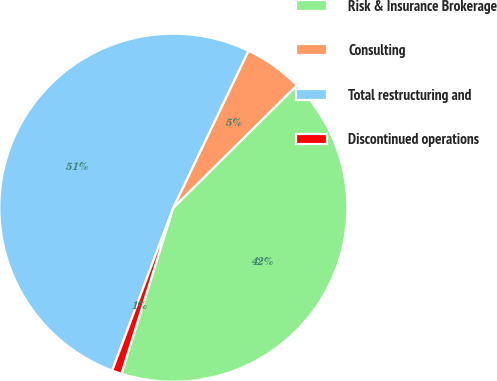Convert chart. <chart><loc_0><loc_0><loc_500><loc_500><pie_chart><fcel>Risk & Insurance Brokerage<fcel>Consulting<fcel>Total restructuring and<fcel>Discontinued operations<nl><fcel>42.25%<fcel>5.47%<fcel>51.4%<fcel>0.89%<nl></chart> 